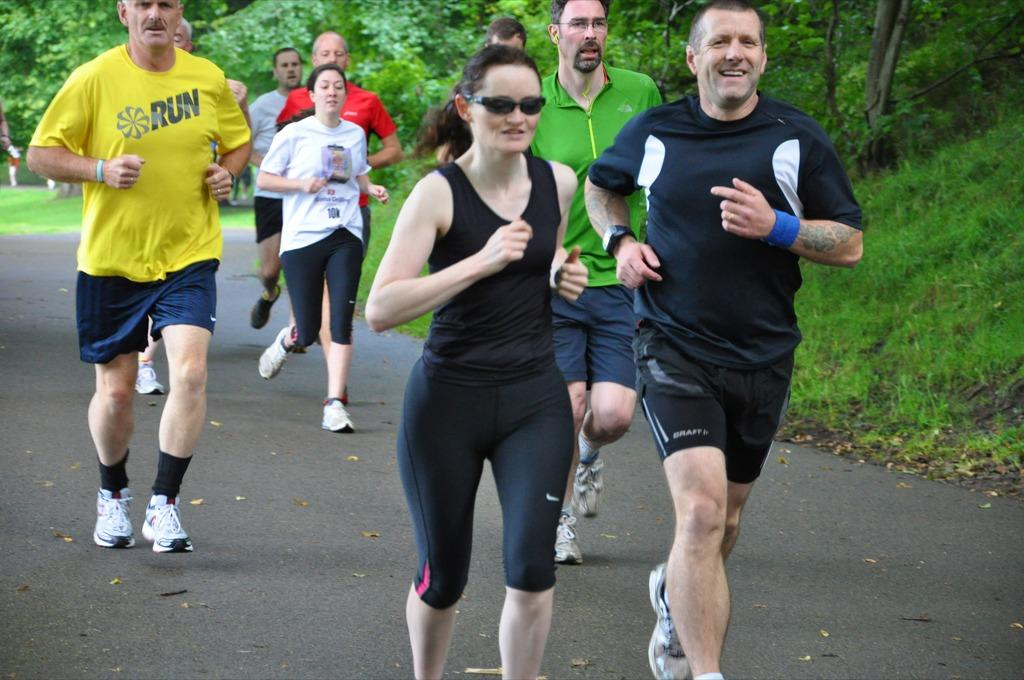What are the people in the image doing? The people in the image are running. Where are the people running? The people are running on a road. What can be seen in the background of the image? There are trees and grass visible in the background of the image. What type of dog is playing during the recess in the image? There is no dog or recess present in the image; it features people running on a road. 